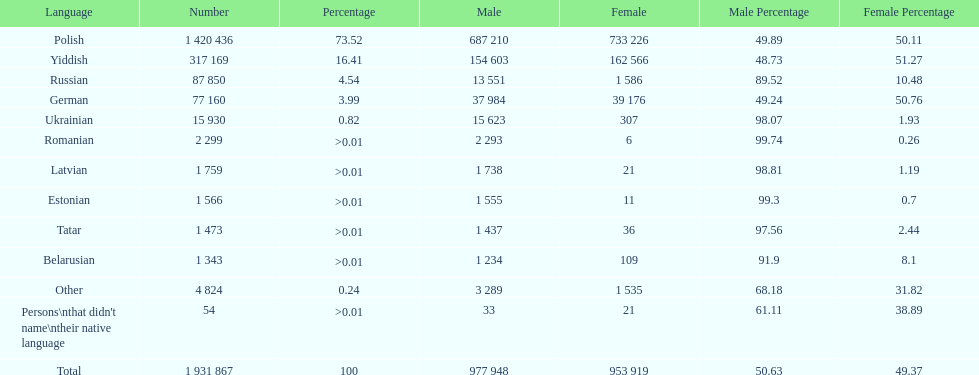What was the next most commonly spoken language in poland after russian? German. 